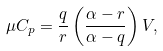<formula> <loc_0><loc_0><loc_500><loc_500>\mu C _ { p } = \frac { q } { r } \left ( \frac { \alpha - r } { \alpha - q } \right ) V ,</formula> 